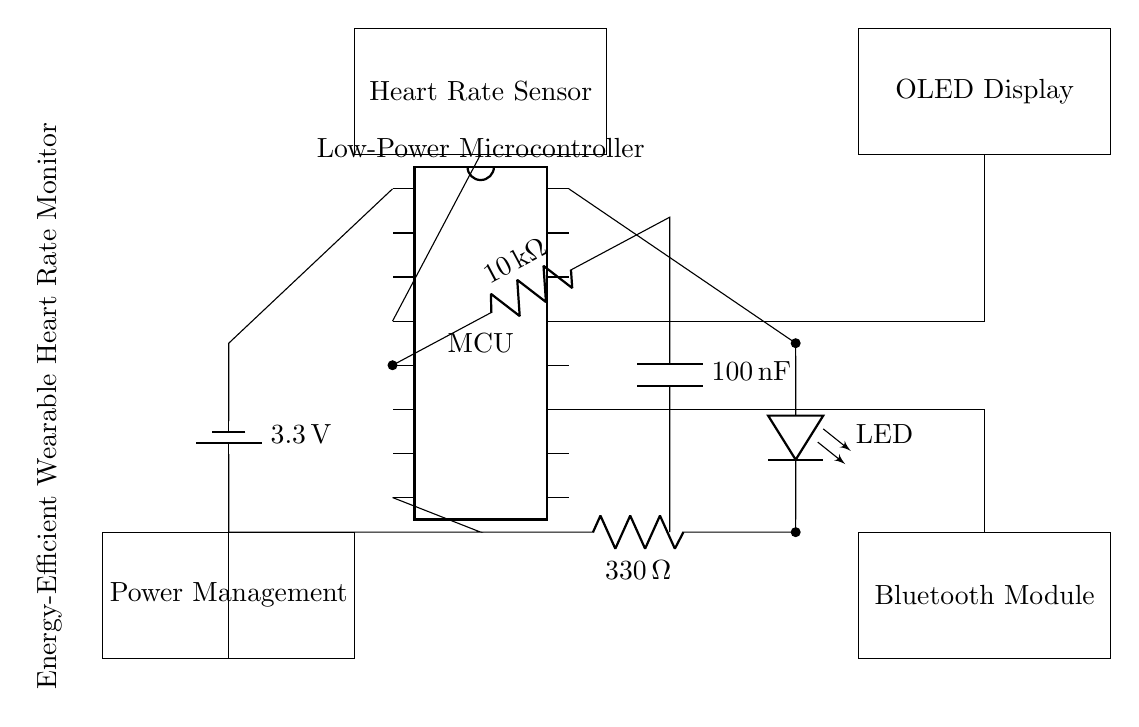What is the total number of components in this circuit? The circuit diagram includes a microcontroller, a heart rate sensor, an LED, a low-pass filter (which consists of a resistor and a capacitor), an OLED display, a Bluetooth module, and a power management unit. Counting these components gives us a total of seven distinct components in the circuit.
Answer: Seven What is the value of the resistor used with the LED? The circuit diagram shows a resistor connected to the LED, and the value indicated next to it is 330 ohms. This value is used to limit the current flowing through the LED to protect it from damage.
Answer: 330 ohms How is the heart rate sensor connected to the microcontroller? In the circuit, a direct connection line runs from the heart rate sensor to the pin labeled on the microcontroller at pin 4. This indicates that the heart rate sensor outputs its signal directly to this specific pin for processing.
Answer: Pin 4 What is the purpose of the low-pass filter in this circuit? The low-pass filter is designed to remove high-frequency noise from the signal received from the heart rate sensor before it is processed by the microcontroller. The presence of a resistor (10 k ohm) and a capacitor (100 nanofarads) suggests that this filter will only allow lower frequency signals through, thus improving the accuracy of the heart rate reading.
Answer: Noise reduction What voltage does the battery supply to the circuit? The circuit uses a battery labeled with a voltage of 3.3 volts, which means this is the potential difference provided by the battery to power the entire circuit, including the microcontroller and other components.
Answer: 3.3 volts What component is used for wireless communication in this circuit? According to the diagram, there is a box labeled “Bluetooth Module” which indicates that this component is used for wireless communication. This module allows the wearable heart rate monitor to transmit data wirelessly to other devices such as smartphones or computers.
Answer: Bluetooth Module Which component handles power management in the circuit? The circuit includes a section labeled "Power Management," indicating that it is responsible for managing the power distribution and perhaps regulating voltage levels for various components in the heart rate monitor, ensuring that they all operate efficiently.
Answer: Power Management 